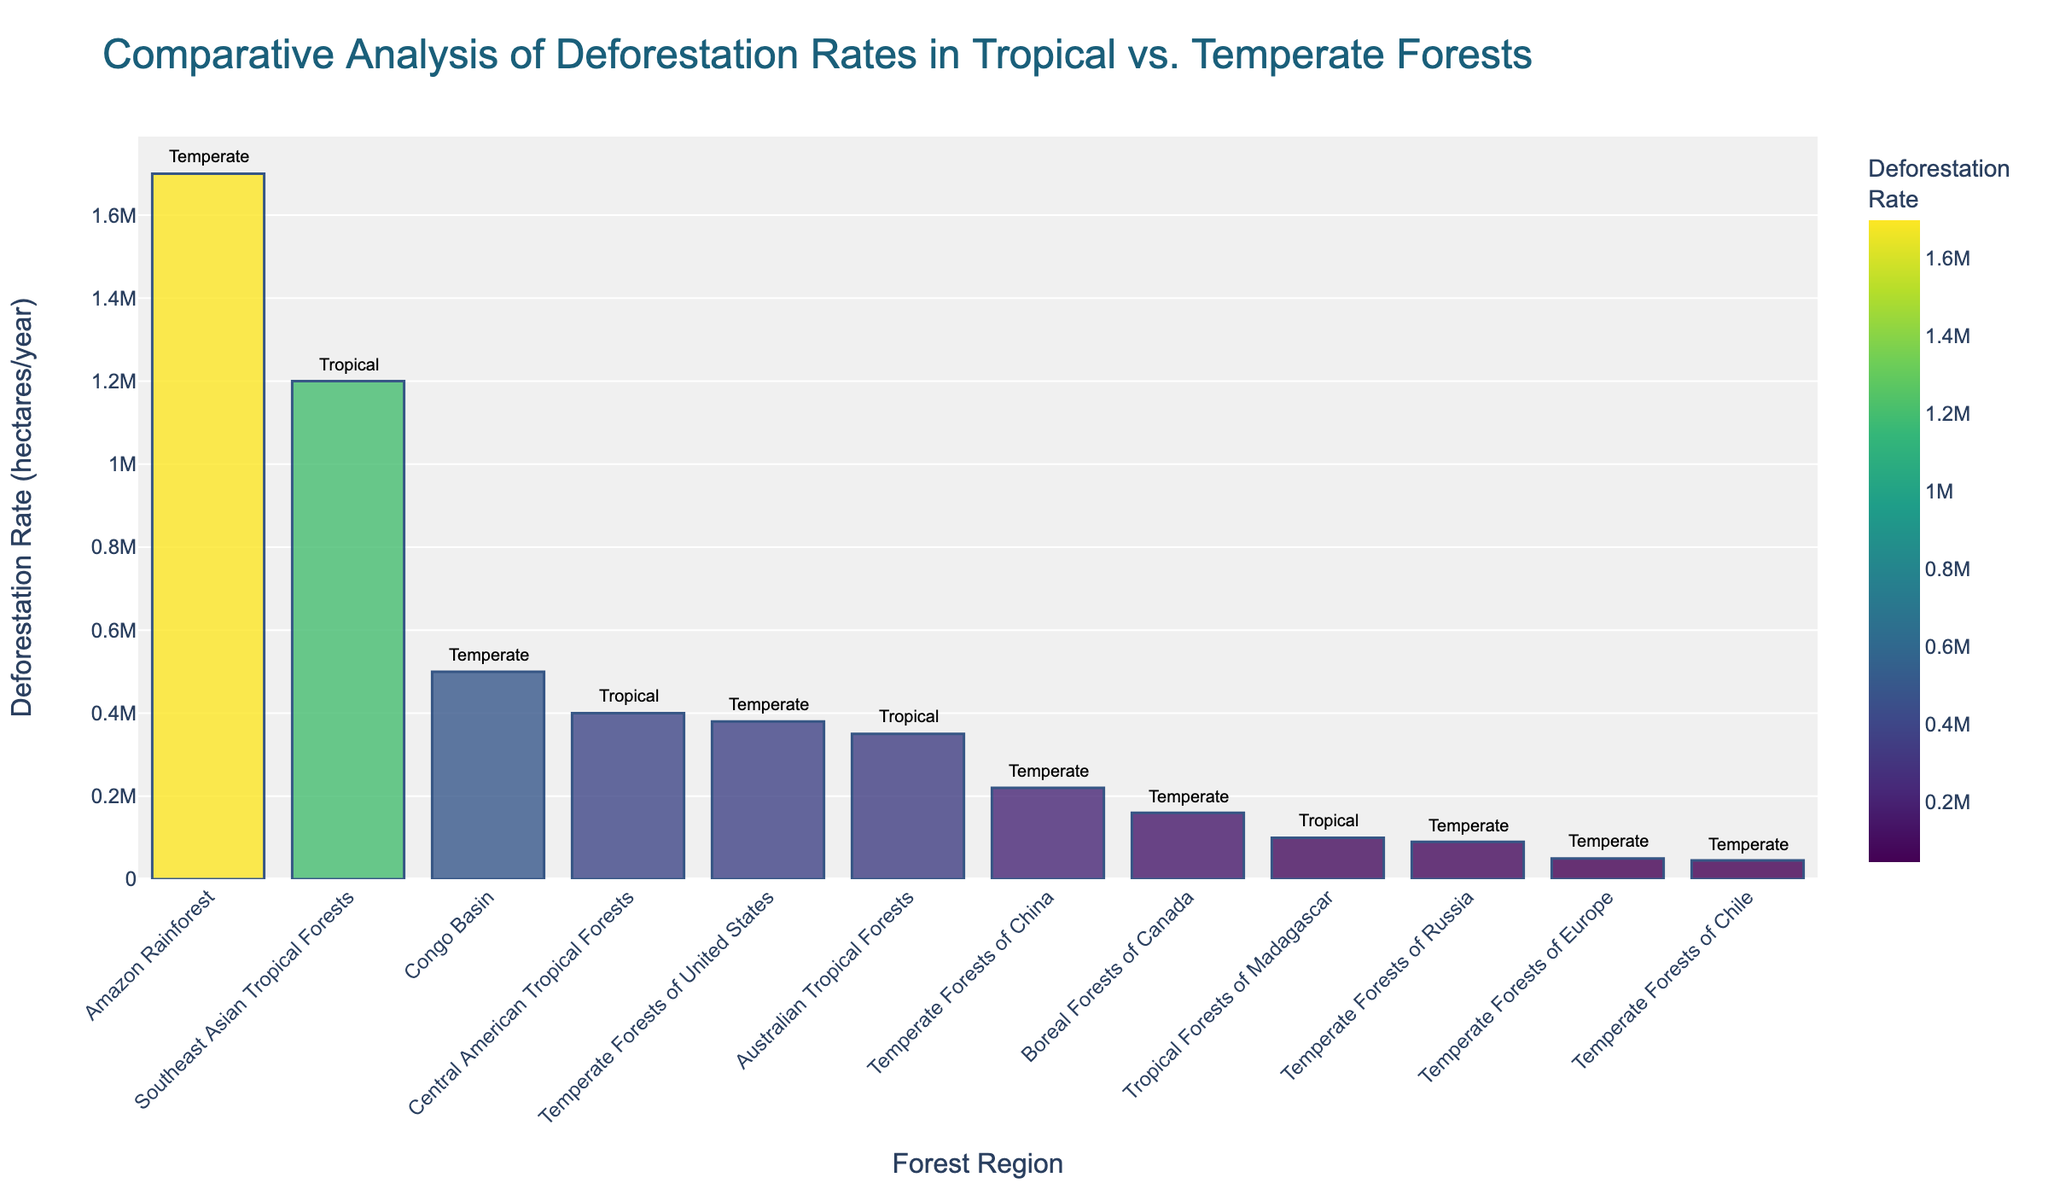Which region has the highest deforestation rate? To identify the region with the highest deforestation rate, look for the tallest bar in the chart. The tallest bar corresponds to the Amazon Rainforest.
Answer: Amazon Rainforest Which temperate forest region has the lowest deforestation rate? To find the temperate forest region with the lowest deforestation rate, locate the shortest bar among the temperate forest regions. Temperate Forests of Chile have the shortest bar.
Answer: Temperate Forests of Chile What is the combined deforestation rate of all tropical forests? Add the deforestation rates of all tropical forest regions: Amazon Rainforest (1,700,000) + Congo Basin (500,000) + Southeast Asian Tropical Forests (1,200,000) + Australian Tropical Forests (350,000) + Central American Tropical Forests (400,000) + Tropical Forests of Madagascar (100,000) = 4,250,000 hectares per year.
Answer: 4,250,000 How does the deforestation rate of the Boreal Forests of Canada compare to the Amazon Rainforest? The deforestation rate of the Boreal Forests of Canada (160,000 hectares/year) is significantly lower than that of the Amazon Rainforest (1,700,000 hectares/year).
Answer: Lower Which forest type, tropical or temperate, has more regions listed in the chart? Count the number of regions for each type: Tropical Forests (Amazon Rainforest, Congo Basin, Southeast Asian Tropical Forests, Australian Tropical Forests, Central American Tropical Forests, Tropical Forests of Madagascar) – 6 regions, Temperate Forests (Boreal Forests of Canada, Temperate Forests of Europe, Temperate Forests of United States, Temperate Forests of China, Temperate Forests of Russia, Temperate Forests of Chile) – 6 regions. Both types have the same number of regions listed.
Answer: Equal What is the difference in the deforestation rate between the largest tropical forest and the largest temperate forest? The largest tropical forest, the Amazon Rainforest, has a deforestation rate of 1,700,000 hectares/year. The largest temperate forest, the Temperate Forests of the United States, has a deforestation rate of 380,000 hectares/year. The difference is 1,700,000 - 380,000 = 1,320,000 hectares/year.
Answer: 1,320,000 Which region shows a deforestation rate closest to 100,000 hectares/year? Identify the region with the bar length closest to 100,000 hectares/year. Tropical Forests of Madagascar have a deforestation rate of exactly 100,000 hectares/year.
Answer: Tropical Forests of Madagascar Which forest region has a deforestation rate between 300,000 and 400,000 hectares/year? Look for the bar whose height indicates a deforestation rate between 300,000 and 400,000 hectares/year. The regions are Australian Tropical Forests (350,000 hectares/year) and Temperate Forests of the United States (380,000 hectares/year).
Answer: Australian Tropical Forests and Temperate Forests of the United States What is the average deforestation rate among temperate forests? Sum the deforestation rates of Temperate Forests: Boreal Forests of Canada (160,000) + Temperate Forests of Europe (50,000) + Temperate Forests of the United States (380,000) + Temperate Forests of China (220,000) + Temperate Forests of Russia (90,000) + Temperate Forests of Chile (45,000) = 945,000. Divide by the number of temperate regions: 945,000 / 6 ≈ 157,500 hectares/year.
Answer: 157,500 Which regions have deforestation rates greater than 200,000 hectares/year? Identify the regions with bars corresponding to deforestation rates above 200,000 hectares/year: Amazon Rainforest (1,700,000), Southeast Asian Tropical Forests (1,200,000), Congo Basin (500,000), Central American Tropical Forests (400,000), Australian Tropical Forests (350,000), Temperate Forests of the United States (380,000), and Temperate Forests of China (220,000).
Answer: Amazon Rainforest, Southeast Asian Tropical Forests, Congo Basin, Central American Tropical Forests, Australian Tropical Forests, Temperate Forests of the United States, Temperate Forests of China 